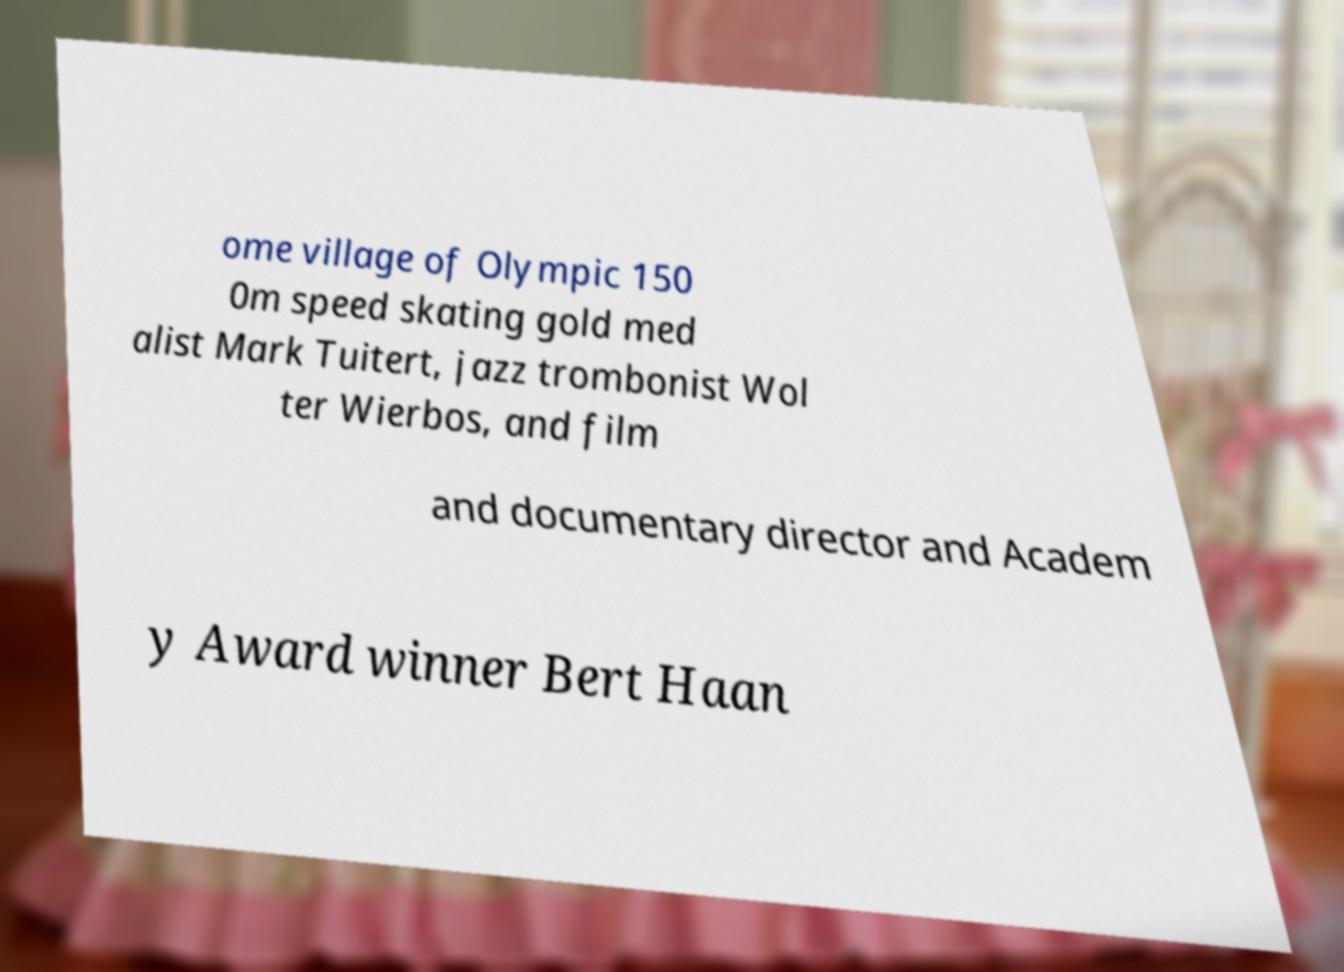What messages or text are displayed in this image? I need them in a readable, typed format. ome village of Olympic 150 0m speed skating gold med alist Mark Tuitert, jazz trombonist Wol ter Wierbos, and film and documentary director and Academ y Award winner Bert Haan 